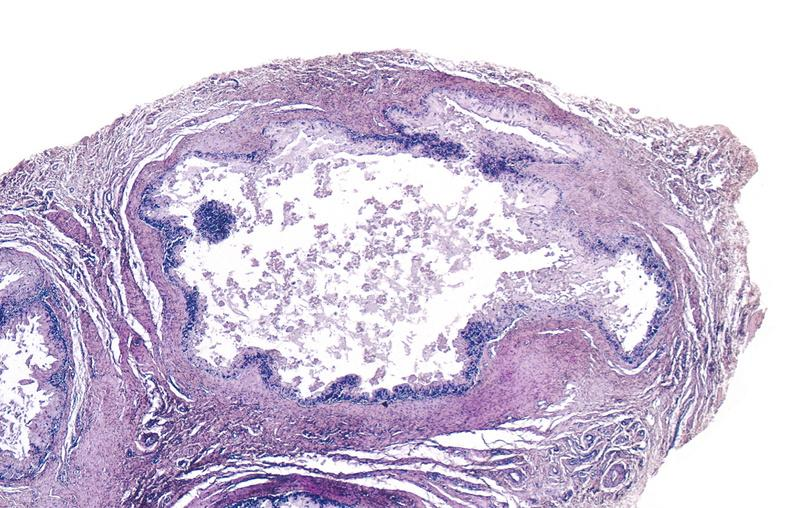s accessories present?
Answer the question using a single word or phrase. No 